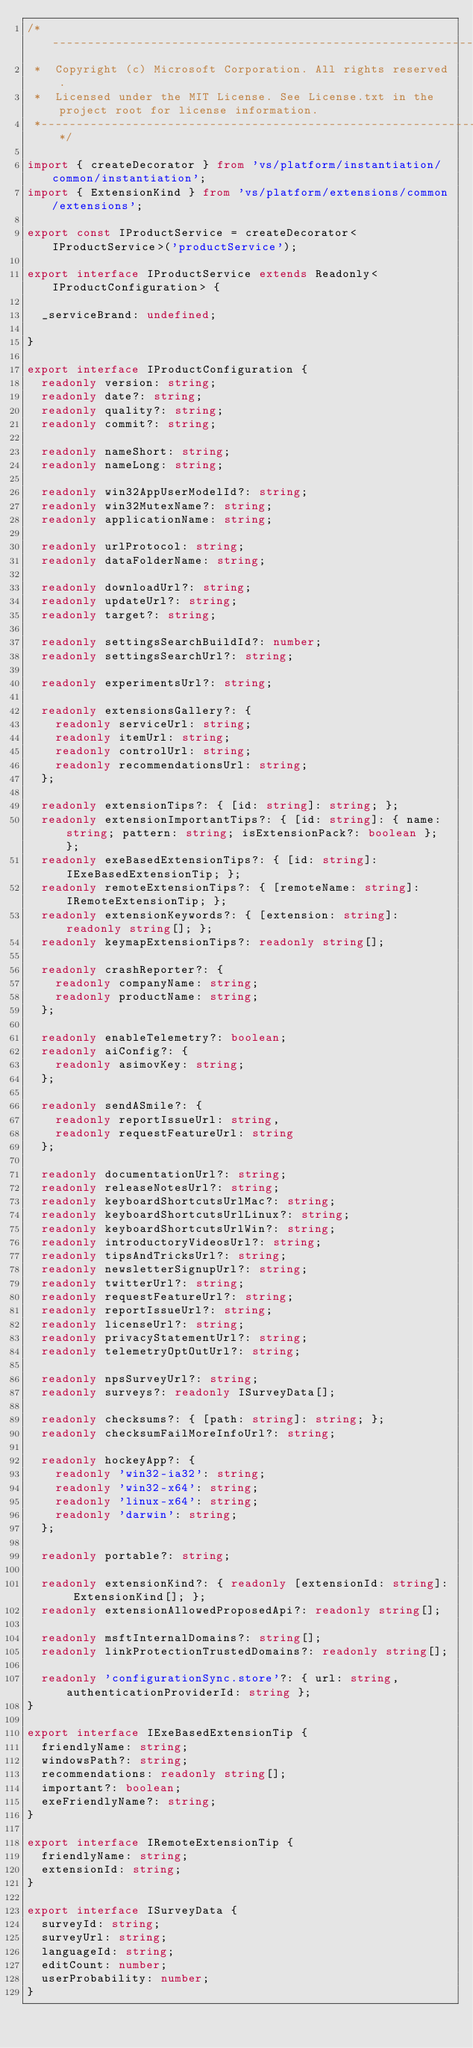Convert code to text. <code><loc_0><loc_0><loc_500><loc_500><_TypeScript_>/*---------------------------------------------------------------------------------------------
 *  Copyright (c) Microsoft Corporation. All rights reserved.
 *  Licensed under the MIT License. See License.txt in the project root for license information.
 *--------------------------------------------------------------------------------------------*/

import { createDecorator } from 'vs/platform/instantiation/common/instantiation';
import { ExtensionKind } from 'vs/platform/extensions/common/extensions';

export const IProductService = createDecorator<IProductService>('productService');

export interface IProductService extends Readonly<IProductConfiguration> {

	_serviceBrand: undefined;

}

export interface IProductConfiguration {
	readonly version: string;
	readonly date?: string;
	readonly quality?: string;
	readonly commit?: string;

	readonly nameShort: string;
	readonly nameLong: string;

	readonly win32AppUserModelId?: string;
	readonly win32MutexName?: string;
	readonly applicationName: string;

	readonly urlProtocol: string;
	readonly dataFolderName: string;

	readonly downloadUrl?: string;
	readonly updateUrl?: string;
	readonly target?: string;

	readonly settingsSearchBuildId?: number;
	readonly settingsSearchUrl?: string;

	readonly experimentsUrl?: string;

	readonly extensionsGallery?: {
		readonly serviceUrl: string;
		readonly itemUrl: string;
		readonly controlUrl: string;
		readonly recommendationsUrl: string;
	};

	readonly extensionTips?: { [id: string]: string; };
	readonly extensionImportantTips?: { [id: string]: { name: string; pattern: string; isExtensionPack?: boolean }; };
	readonly exeBasedExtensionTips?: { [id: string]: IExeBasedExtensionTip; };
	readonly remoteExtensionTips?: { [remoteName: string]: IRemoteExtensionTip; };
	readonly extensionKeywords?: { [extension: string]: readonly string[]; };
	readonly keymapExtensionTips?: readonly string[];

	readonly crashReporter?: {
		readonly companyName: string;
		readonly productName: string;
	};

	readonly enableTelemetry?: boolean;
	readonly aiConfig?: {
		readonly asimovKey: string;
	};

	readonly sendASmile?: {
		readonly reportIssueUrl: string,
		readonly requestFeatureUrl: string
	};

	readonly documentationUrl?: string;
	readonly releaseNotesUrl?: string;
	readonly keyboardShortcutsUrlMac?: string;
	readonly keyboardShortcutsUrlLinux?: string;
	readonly keyboardShortcutsUrlWin?: string;
	readonly introductoryVideosUrl?: string;
	readonly tipsAndTricksUrl?: string;
	readonly newsletterSignupUrl?: string;
	readonly twitterUrl?: string;
	readonly requestFeatureUrl?: string;
	readonly reportIssueUrl?: string;
	readonly licenseUrl?: string;
	readonly privacyStatementUrl?: string;
	readonly telemetryOptOutUrl?: string;

	readonly npsSurveyUrl?: string;
	readonly surveys?: readonly ISurveyData[];

	readonly checksums?: { [path: string]: string; };
	readonly checksumFailMoreInfoUrl?: string;

	readonly hockeyApp?: {
		readonly 'win32-ia32': string;
		readonly 'win32-x64': string;
		readonly 'linux-x64': string;
		readonly 'darwin': string;
	};

	readonly portable?: string;

	readonly extensionKind?: { readonly [extensionId: string]: ExtensionKind[]; };
	readonly extensionAllowedProposedApi?: readonly string[];

	readonly msftInternalDomains?: string[];
	readonly linkProtectionTrustedDomains?: readonly string[];

	readonly 'configurationSync.store'?: { url: string, authenticationProviderId: string };
}

export interface IExeBasedExtensionTip {
	friendlyName: string;
	windowsPath?: string;
	recommendations: readonly string[];
	important?: boolean;
	exeFriendlyName?: string;
}

export interface IRemoteExtensionTip {
	friendlyName: string;
	extensionId: string;
}

export interface ISurveyData {
	surveyId: string;
	surveyUrl: string;
	languageId: string;
	editCount: number;
	userProbability: number;
}
</code> 